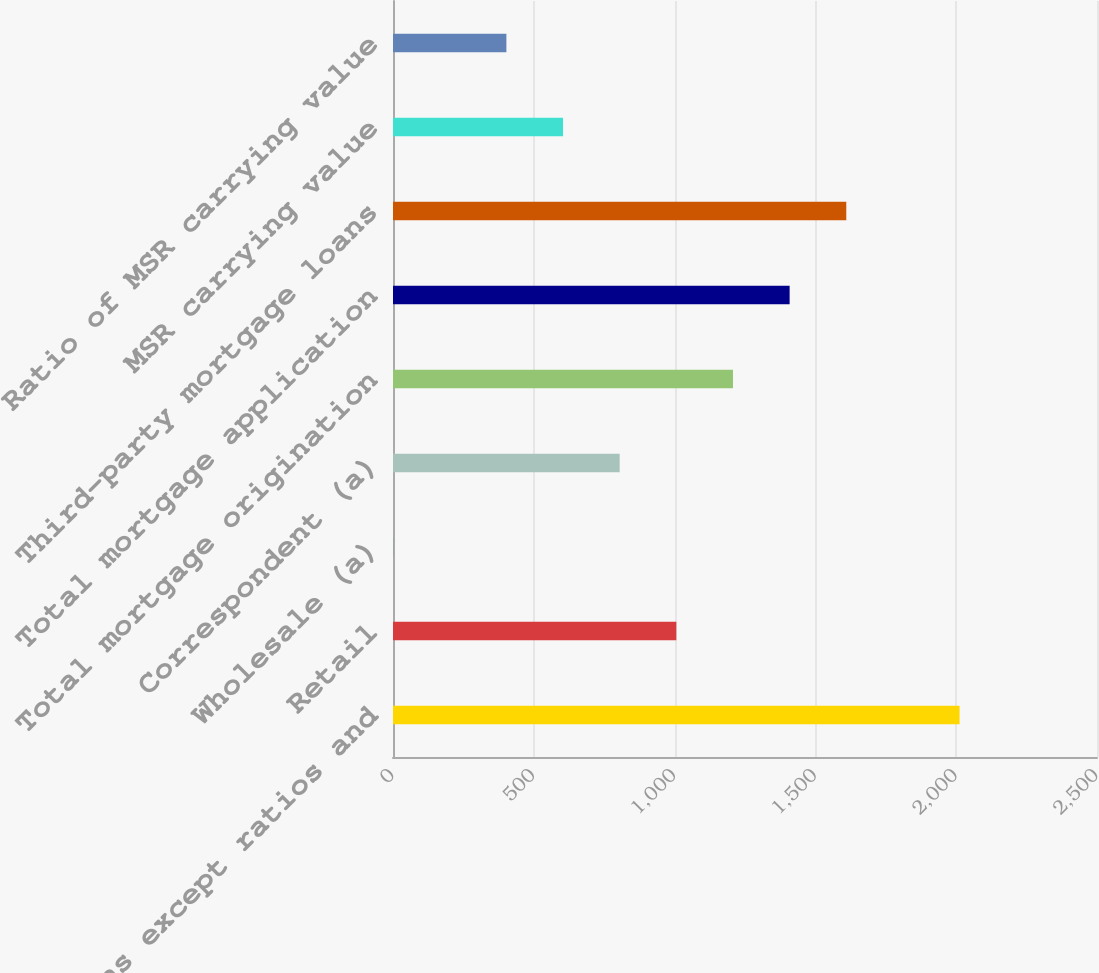Convert chart. <chart><loc_0><loc_0><loc_500><loc_500><bar_chart><fcel>(in millions except ratios and<fcel>Retail<fcel>Wholesale (a)<fcel>Correspondent (a)<fcel>Total mortgage origination<fcel>Total mortgage application<fcel>Third-party mortgage loans<fcel>MSR carrying value<fcel>Ratio of MSR carrying value<nl><fcel>2012<fcel>1006.15<fcel>0.3<fcel>804.98<fcel>1207.32<fcel>1408.49<fcel>1609.66<fcel>603.81<fcel>402.64<nl></chart> 